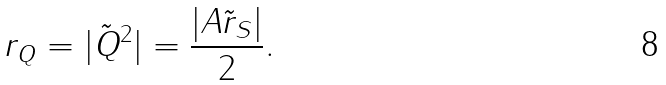<formula> <loc_0><loc_0><loc_500><loc_500>r _ { Q } = | \tilde { Q } ^ { 2 } | = \frac { | A \tilde { r } _ { S } | } { 2 } .</formula> 